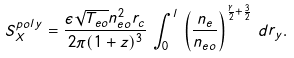Convert formula to latex. <formula><loc_0><loc_0><loc_500><loc_500>S _ { X } ^ { p o l y } = \frac { \epsilon \sqrt { T _ { e o } } n _ { e o } ^ { 2 } r _ { c } } { 2 \pi ( 1 + z ) ^ { 3 } } \, \int _ { 0 } ^ { l } \, \left ( \frac { n _ { e } } { n _ { e o } } \right ) ^ { \frac { \gamma } { 2 } + \frac { 3 } { 2 } } \, d r _ { y } .</formula> 